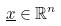Convert formula to latex. <formula><loc_0><loc_0><loc_500><loc_500>\underline { x } \in \mathbb { R } ^ { n }</formula> 